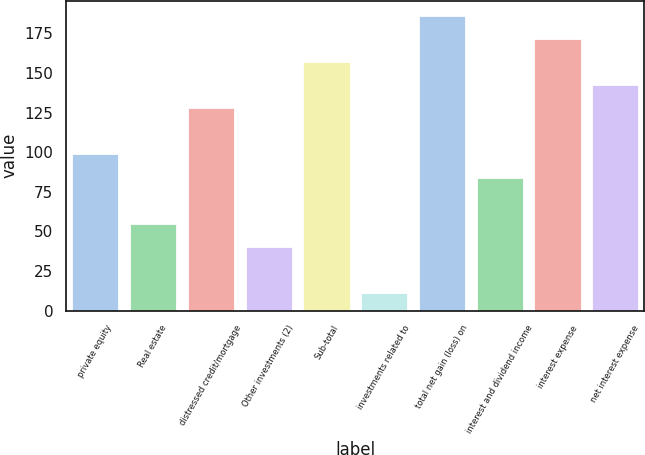<chart> <loc_0><loc_0><loc_500><loc_500><bar_chart><fcel>private equity<fcel>Real estate<fcel>distressed credit/mortgage<fcel>Other investments (2)<fcel>Sub-total<fcel>investments related to<fcel>total net gain (loss) on<fcel>interest and dividend income<fcel>interest expense<fcel>net interest expense<nl><fcel>98.6<fcel>54.8<fcel>127.8<fcel>40.2<fcel>157<fcel>11<fcel>186.2<fcel>84<fcel>171.6<fcel>142.4<nl></chart> 